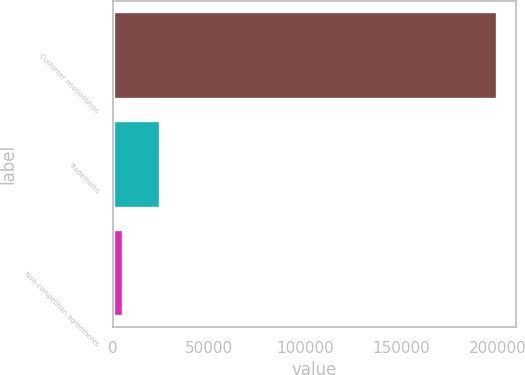Convert chart to OTSL. <chart><loc_0><loc_0><loc_500><loc_500><bar_chart><fcel>Customer relationships<fcel>Trademarks<fcel>Non-competition agreements<nl><fcel>199741<fcel>24520.9<fcel>5052<nl></chart> 